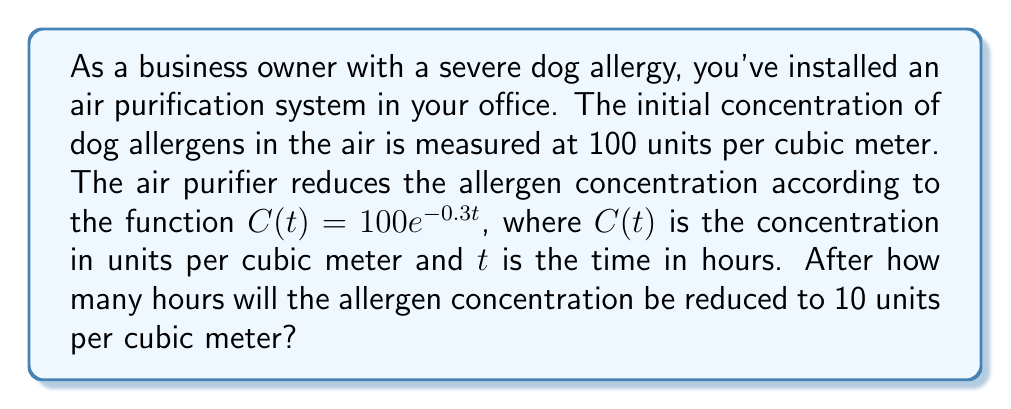What is the answer to this math problem? To solve this problem, we need to use the properties of logarithms and exponential functions. Let's approach this step-by-step:

1) We start with the equation:
   $$C(t) = 100e^{-0.3t}$$

2) We want to find $t$ when $C(t) = 10$. So, we can set up the equation:
   $$10 = 100e^{-0.3t}$$

3) Divide both sides by 100:
   $$0.1 = e^{-0.3t}$$

4) Now, we can take the natural logarithm of both sides. Remember, $\ln(e^x) = x$:
   $$\ln(0.1) = \ln(e^{-0.3t})$$
   $$\ln(0.1) = -0.3t$$

5) Solve for $t$ by dividing both sides by -0.3:
   $$\frac{\ln(0.1)}{-0.3} = t$$

6) Calculate the value:
   $$t = \frac{\ln(0.1)}{-0.3} \approx 7.675$$

Therefore, it will take approximately 7.675 hours for the allergen concentration to reduce to 10 units per cubic meter.
Answer: Approximately 7.675 hours 